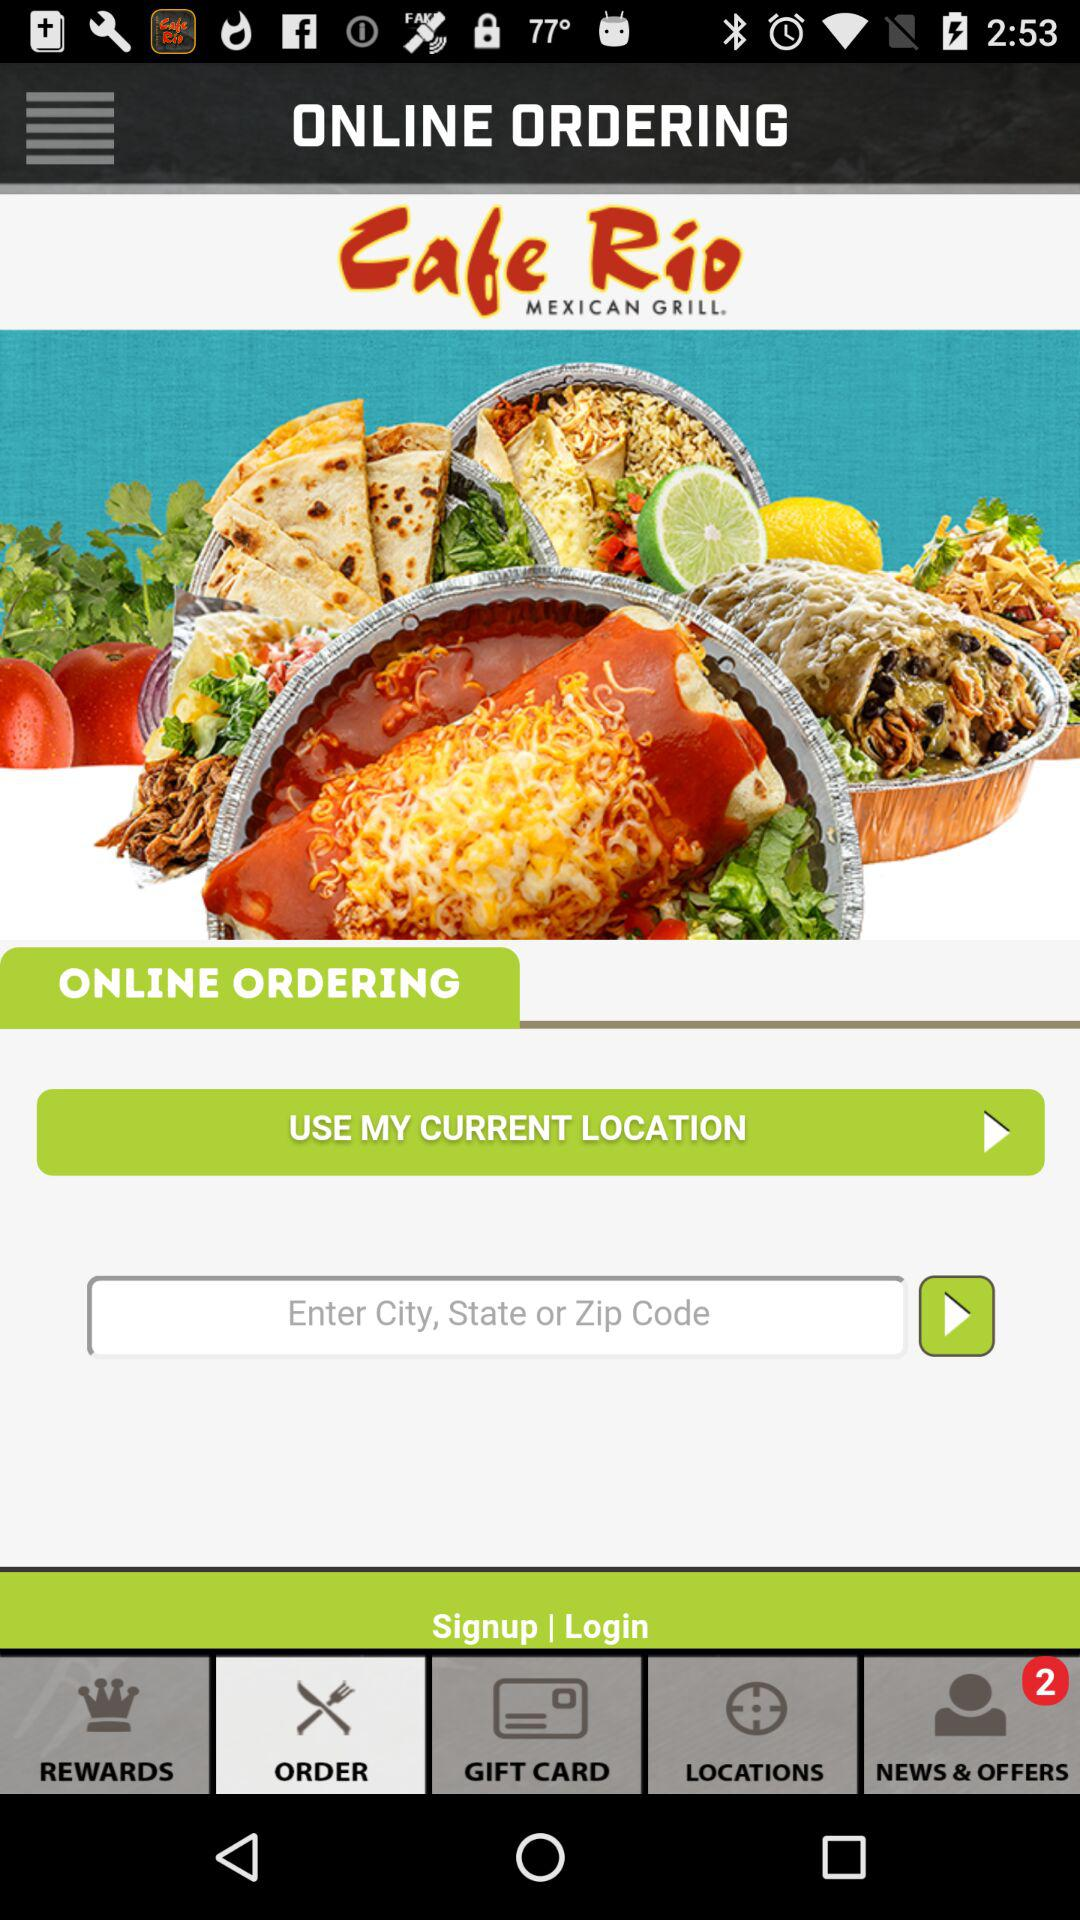What is the name of the application? The name of the application is "Cafe Rio". 